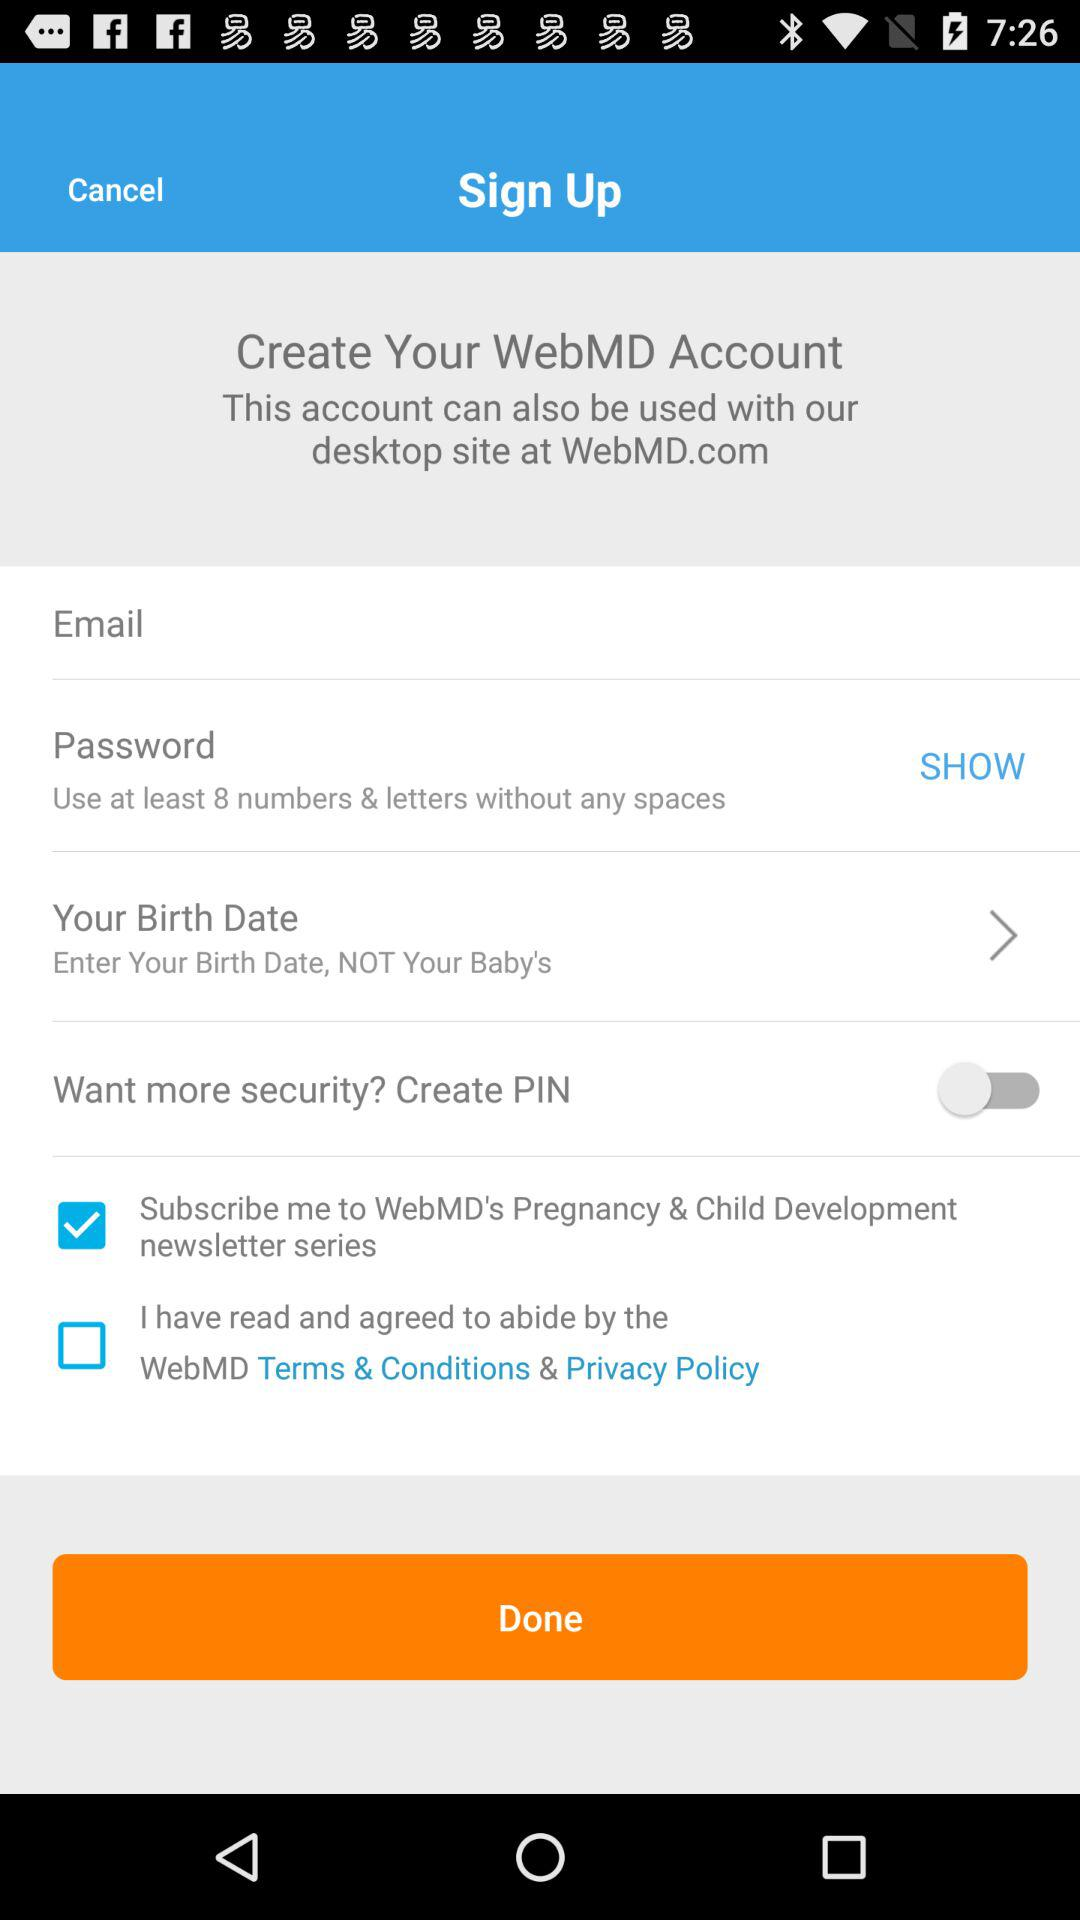What account can we create? The account you can create is "WebMD Account". 